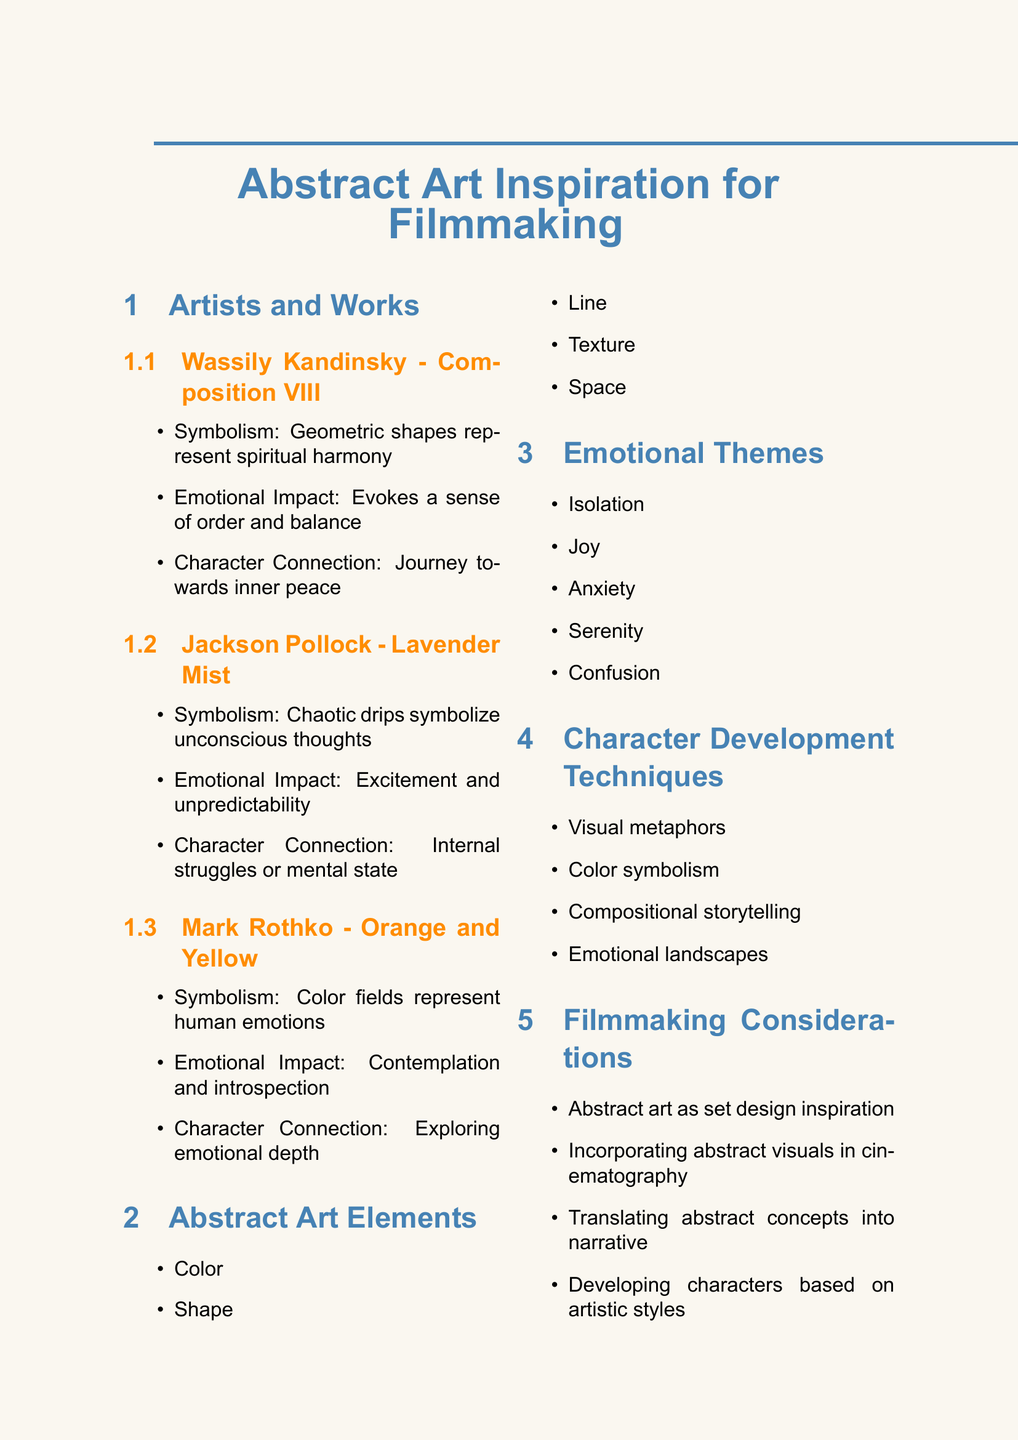What is the title of Wassily Kandinsky's work? The document lists "Composition VIII" as the title of Wassily Kandinsky's work.
Answer: Composition VIII What emotion does Jackson Pollock's "Lavender Mist" evoke? According to the document, "Lavender Mist" creates feelings of excitement and unpredictability.
Answer: Excitement and unpredictability What does Mark Rothko's "Orange and Yellow" symbolize? The document states that color fields in "Orange and Yellow" represent human emotions.
Answer: Human emotions Which character development technique involves visual representations? The document mentions "Visual metaphors" as a character development technique that involves visual representations.
Answer: Visual metaphors What emotional theme is associated with uncertainty? The document lists "Confusion" as an emotional theme associated with uncertainty.
Answer: Confusion Which abstract artist is connected to inner peace? The document connects Wassily Kandinsky's work to a character's journey towards inner peace.
Answer: Wassily Kandinsky How many abstract art elements are listed in the document? The document provides a list of five abstract art elements.
Answer: Five Which artist's work may reflect a character's internal struggles? Jackson Pollock's "Lavender Mist" is identified in the document as possibly reflecting a character's internal struggles.
Answer: Jackson Pollock What does the document suggest about abstract art in filmmaking? It suggests developing characters based on artistic styles or movements as a filmmaking consideration.
Answer: Developing characters based on artistic styles or movements 